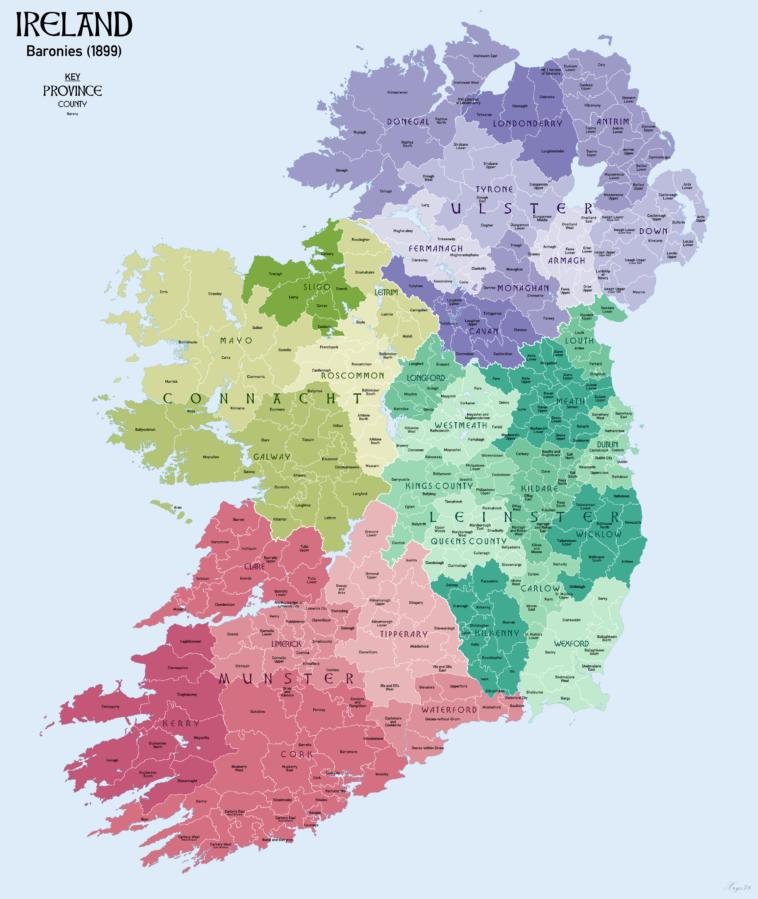Outline some significant characteristics in this image. Ireland has four provinces. The provinces of Connacht and Leinster share borders with the province of Munster. Munster is the province located on the south of Ireland. Ulster, the northernmost province of Ireland, lies to the north of Ireland. The Connacht province has five counties. 